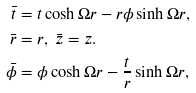<formula> <loc_0><loc_0><loc_500><loc_500>\bar { t } & = t \cosh \Omega r - r \phi \sinh \Omega r , \\ \bar { r } & = r , \text { } \bar { z } = z . \\ \bar { \phi } & = \phi \cosh \Omega r - \frac { t } { r } \sinh \Omega r ,</formula> 